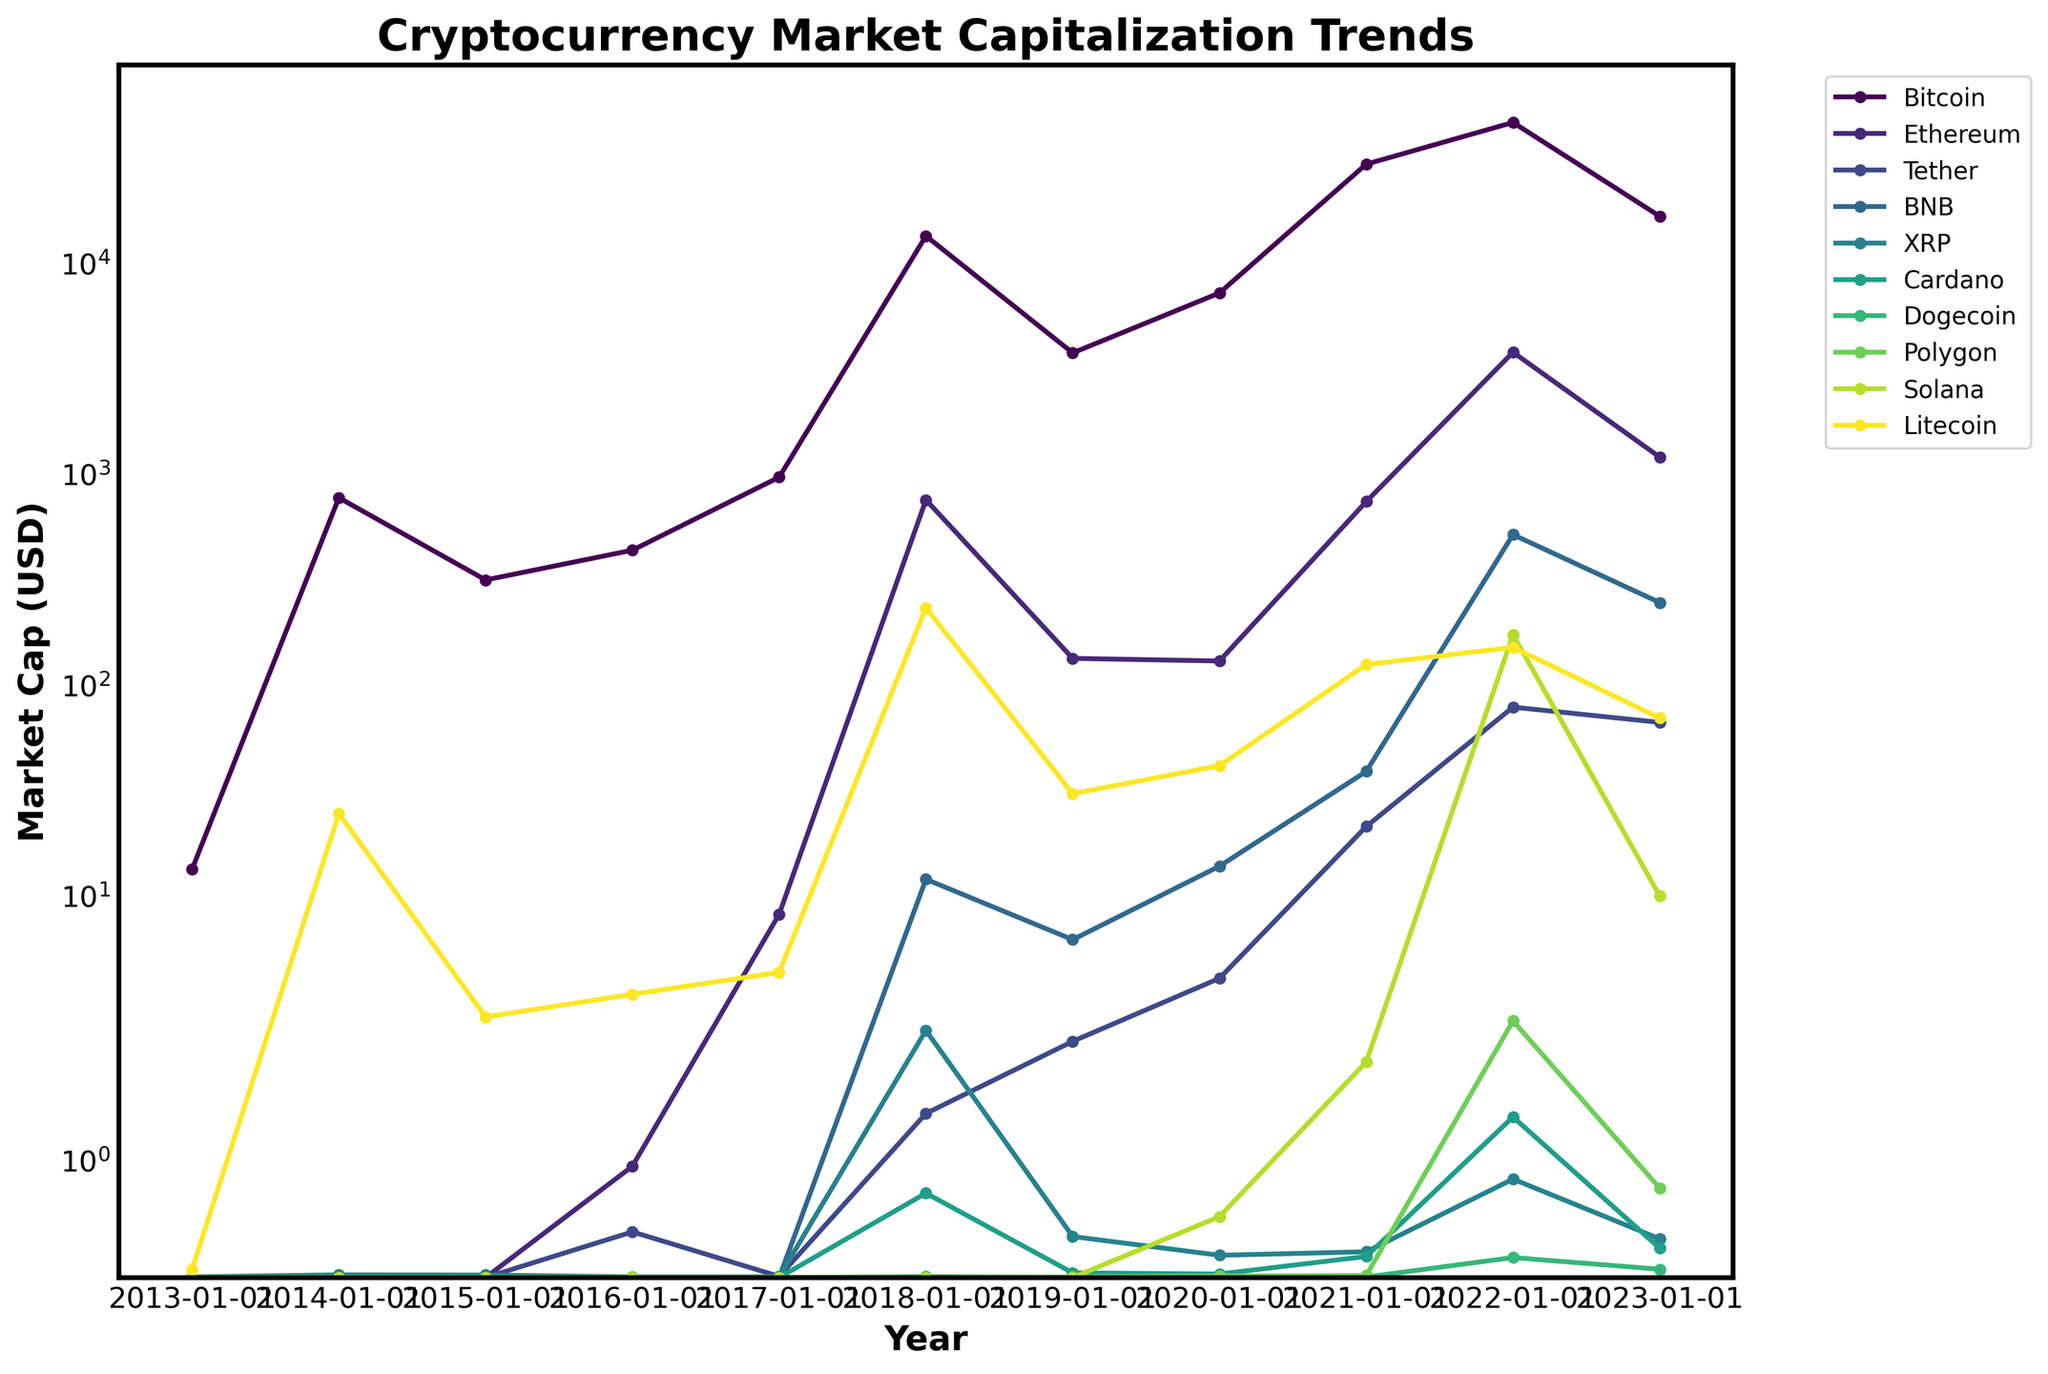What is the highest market capitalization for Bitcoin over the past decade? First, locate the line representing Bitcoin, which is shown with a specific color. Then, find the highest point on this line and read the corresponding value on the y-axis.
Answer: 46311.41 Which cryptocurrency had the highest market capitalization in 2018? Look at the data point for each cryptocurrency in the year 2018. The line reaching the highest point in that year determines the cryptocurrency with the highest market cap.
Answer: Bitcoin Between Bitcoin and Ethereum, which had a higher market capitalization in 2021, and by how much? Identify the lines for Bitcoin and Ethereum. Note their respective values for 2021 from the y-axis. Subtract Ethereum's value from Bitcoin's value to get the difference.
Answer: Bitcoin, difference: 28635.53 How did the market capitalization of Dogecoin in 2023 compare to its value in 2021? Locate the points for Dogecoin in 2023 and 2021 on the graph. Compare the two values directly noted from the y-axis.
Answer: Lower in 2023 Which cryptocurrency showed the most significant increase in market capitalization between 2020 and 2022? Observe the points for each cryptocurrency in 2020 and 2022, and calculate the difference. The cryptocurrency with the largest difference experienced the most significant increase.
Answer: Ethereum What is the most noticeable trend in the market capitalization for Tether from 2019 to 2023? Follow the line representing Tether. Starting from 2019, observe how the line trends over the years until 2023. Note whether the line is generally rising, falling, or stable.
Answer: Increasing What caused the overall market cap to appear skewed towards specific cryptocurrencies? Examine the lines for the market caps of each cryptocurrency. Identify any significant differences in their magnitudes and note which currencies dominate this difference.
Answer: Bitcoin and Ethereum dominate Did the market capitalization of XRP ever surpass BNB between 2018 and 2023? Compare the lines for XRP and BNB from 2018 to 2023. Note any points where the value of XRP's line exceeds that of BNB's line.
Answer: No Which two cryptocurrencies stayed below a market cap of $1 in the early years until they surpassed it later on? Identify lines that start below $1 in the initial years. Check which of these lines eventually cross the $1 mark later.
Answer: Tether and Dogecoin What can you infer about Cardano's market cap trend compared to Polygon from 2021 onwards? Compare the lines for Cardano and Polygon from 2021 onwards. Observe whether they are rising, falling, or stable and note any significant differences.
Answer: Cardano remained relatively low, while Polygon increased sharply 